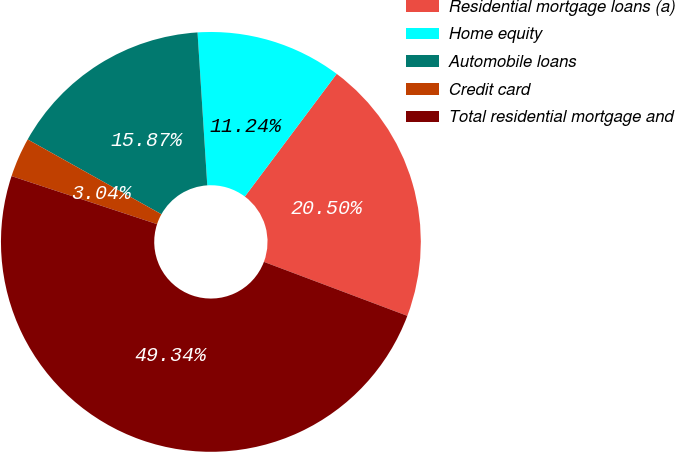Convert chart. <chart><loc_0><loc_0><loc_500><loc_500><pie_chart><fcel>Residential mortgage loans (a)<fcel>Home equity<fcel>Automobile loans<fcel>Credit card<fcel>Total residential mortgage and<nl><fcel>20.5%<fcel>11.24%<fcel>15.87%<fcel>3.04%<fcel>49.34%<nl></chart> 